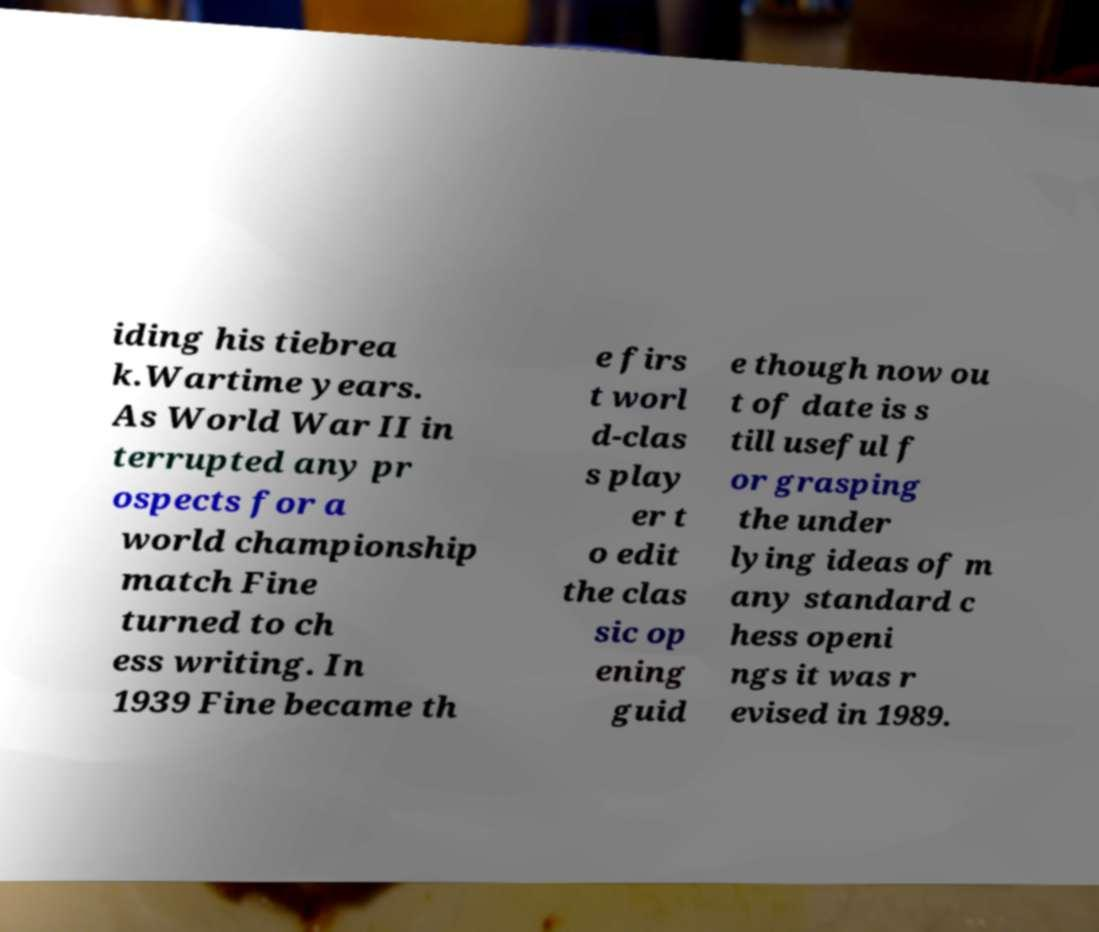Could you assist in decoding the text presented in this image and type it out clearly? iding his tiebrea k.Wartime years. As World War II in terrupted any pr ospects for a world championship match Fine turned to ch ess writing. In 1939 Fine became th e firs t worl d-clas s play er t o edit the clas sic op ening guid e though now ou t of date is s till useful f or grasping the under lying ideas of m any standard c hess openi ngs it was r evised in 1989. 